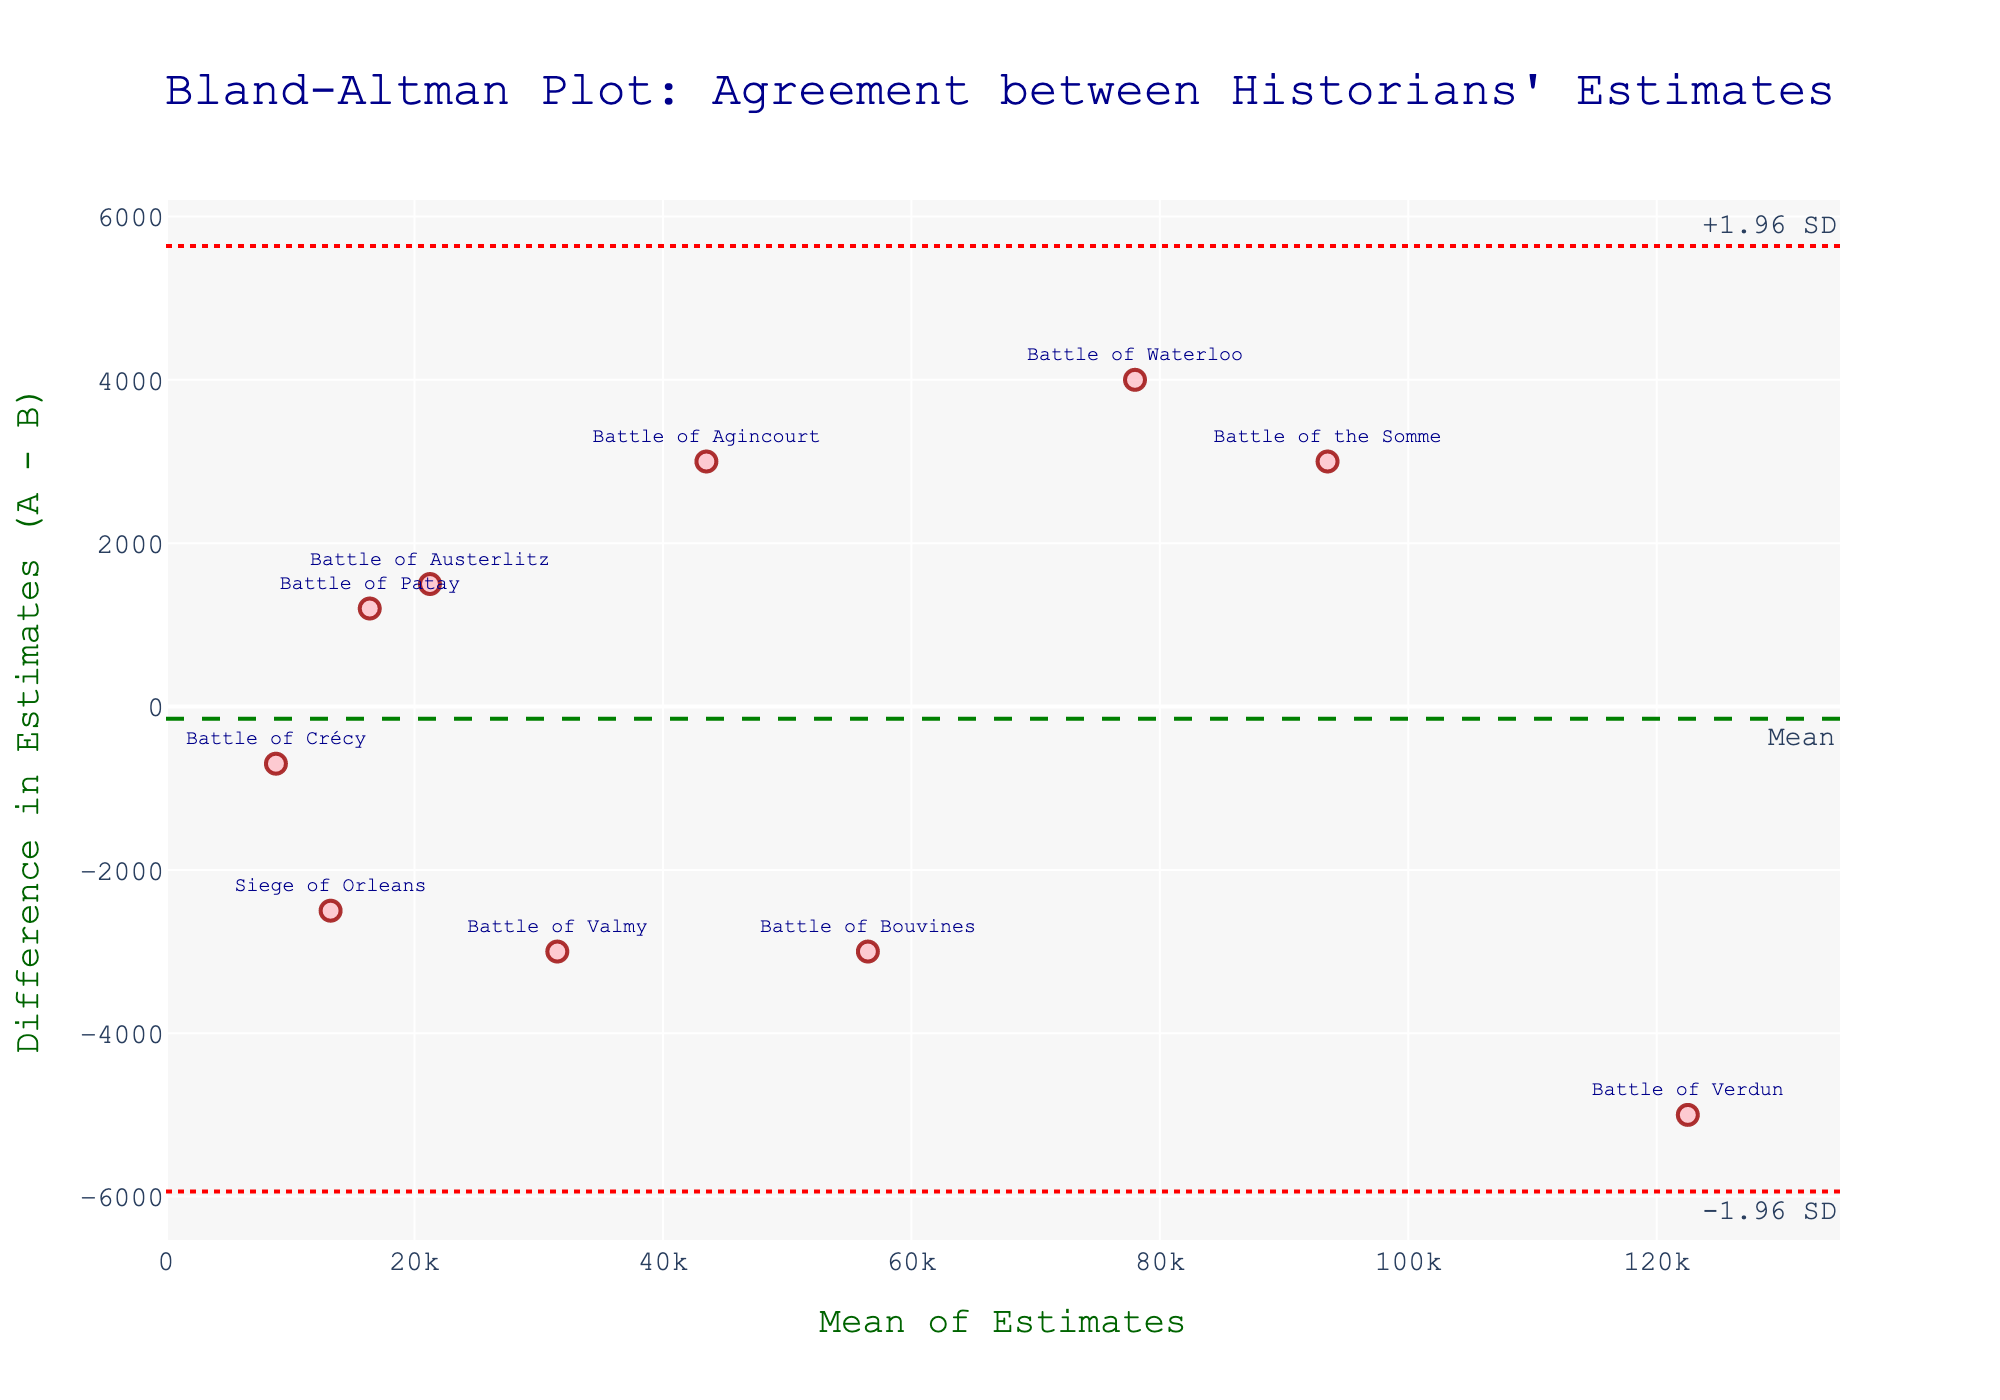What is the title of the plot? The title of the plot is displayed at the top. It reads: "Bland-Altman Plot: Agreement between Historians' Estimates".
Answer: Bland-Altman Plot: Agreement between Historians' Estimates How many battles are represented in the plot? The number of battles can be determined by counting the number of markers or data points on the plot. There are 10 markers, each representing a different battle.
Answer: 10 What does the green dashed line represent? The green dashed line represents the mean difference between the estimates of the two historians. This is a standard feature in Bland-Altman plots to show the central tendency of the differences.
Answer: Mean difference Which battle has the largest disagreement between the historians' estimates? The battle with the largest disagreement will have the marker furthest from the green dashed line (mean difference). By looking at the plot, the "Siege of Orleans" has the largest difference.
Answer: Siege of Orleans Are the estimates of most battles within the limits of agreement? In a Bland-Altman plot, the limits of agreement are indicated by the dotted red lines (+1.96 SD and -1.96 SD). By observing the markers, most are located within these dotted lines.
Answer: Yes How is the Battle of Crécy represented in terms of the mean and difference of estimates? By locating the marker labeled 'Battle of Crécy' on the plot, the mean of estimates and the difference can be inferred from its position. The mean estimate is about the midpoint of the x-axis value, and the difference is the y-axis value where the marker is located.
Answer: Mean ≈ 8850, Difference ≈ -700 Which battle has the smallest mean estimate between the historians? The smallest mean estimate can be identified by locating the leftmost marker on the x-axis. The 'Battle of Crécy' has the smallest mean estimate.
Answer: Battle of Crécy What is the distance between the upper and lower limits of agreement? The distance between the upper and lower limits of agreement can be calculated by subtracting the lower limit (-1.96 SD) from the upper limit (+1.96 SD). This is twice the standard deviation of the differences.
Answer: 2.96 * SD Between which two battles are the estimates the closest? The estimates are the closest for the battles whose markers are nearest to the green dashed line (mean difference). The "Battle of Verdun" shows a minimal difference between historian estimates.
Answer: Battle of Verdun 